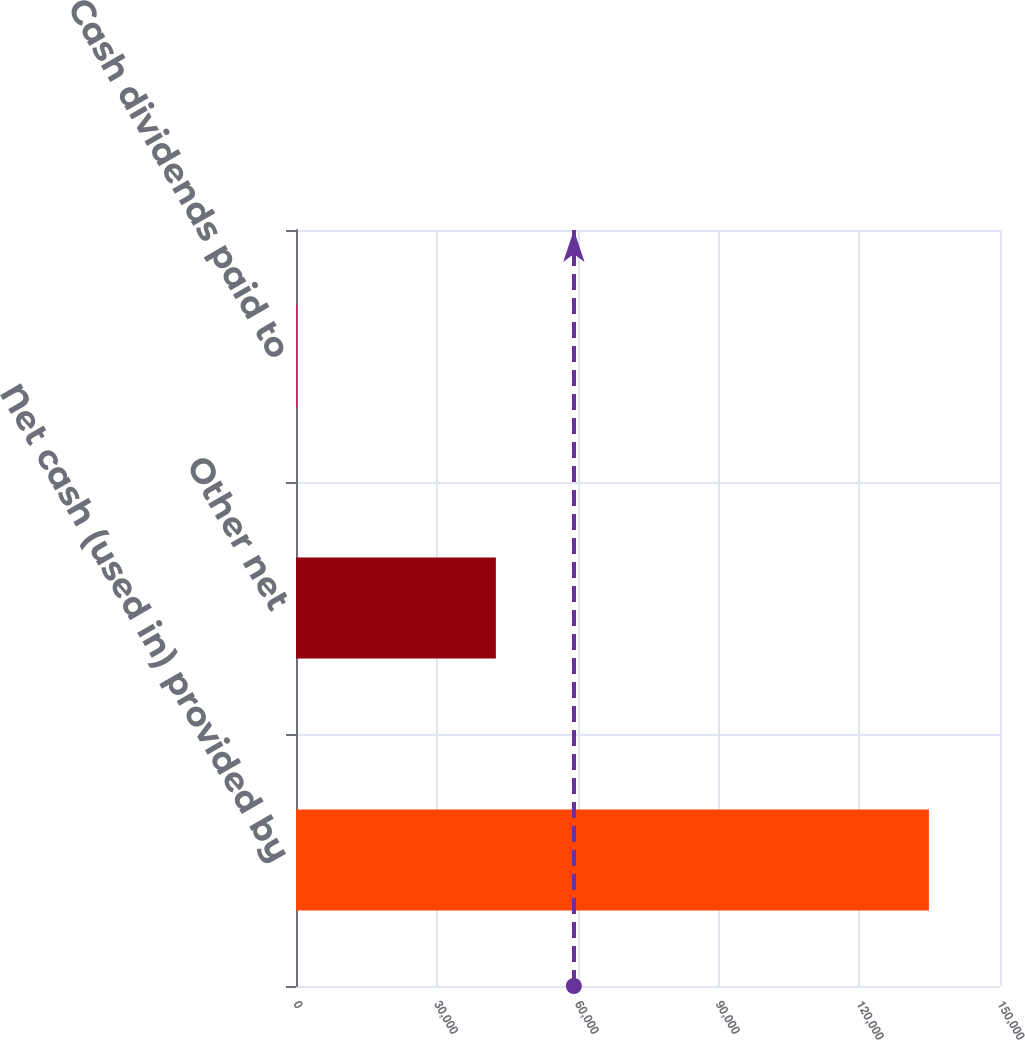Convert chart. <chart><loc_0><loc_0><loc_500><loc_500><bar_chart><fcel>Net cash (used in) provided by<fcel>Other net<fcel>Cash dividends paid to<nl><fcel>134850<fcel>42585<fcel>180<nl></chart> 